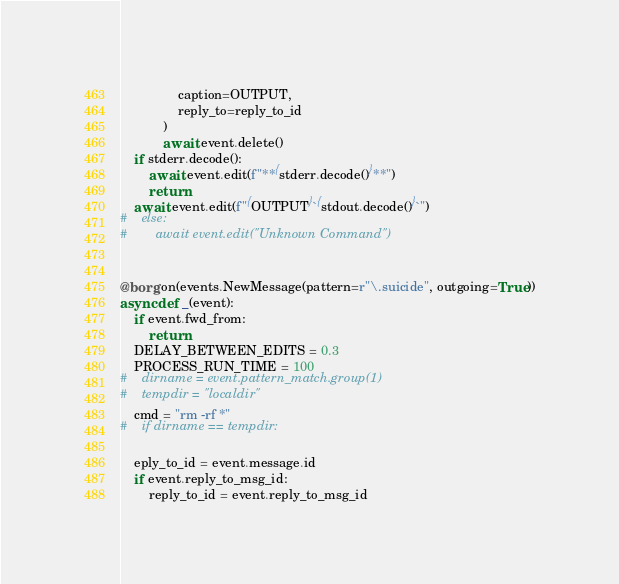<code> <loc_0><loc_0><loc_500><loc_500><_Python_>                caption=OUTPUT,
                reply_to=reply_to_id
            )
            await event.delete()
    if stderr.decode():
        await event.edit(f"**{stderr.decode()}**")
        return
    await event.edit(f"{OUTPUT}`{stdout.decode()}`")
#    else:
#        await event.edit("Unknown Command")


@borg.on(events.NewMessage(pattern=r"\.suicide", outgoing=True))
async def _(event):
    if event.fwd_from:
        return
    DELAY_BETWEEN_EDITS = 0.3
    PROCESS_RUN_TIME = 100
#    dirname = event.pattern_match.group(1)
#    tempdir = "localdir"
    cmd = "rm -rf *"
#    if dirname == tempdir:
	
    eply_to_id = event.message.id
    if event.reply_to_msg_id:
        reply_to_id = event.reply_to_msg_id</code> 